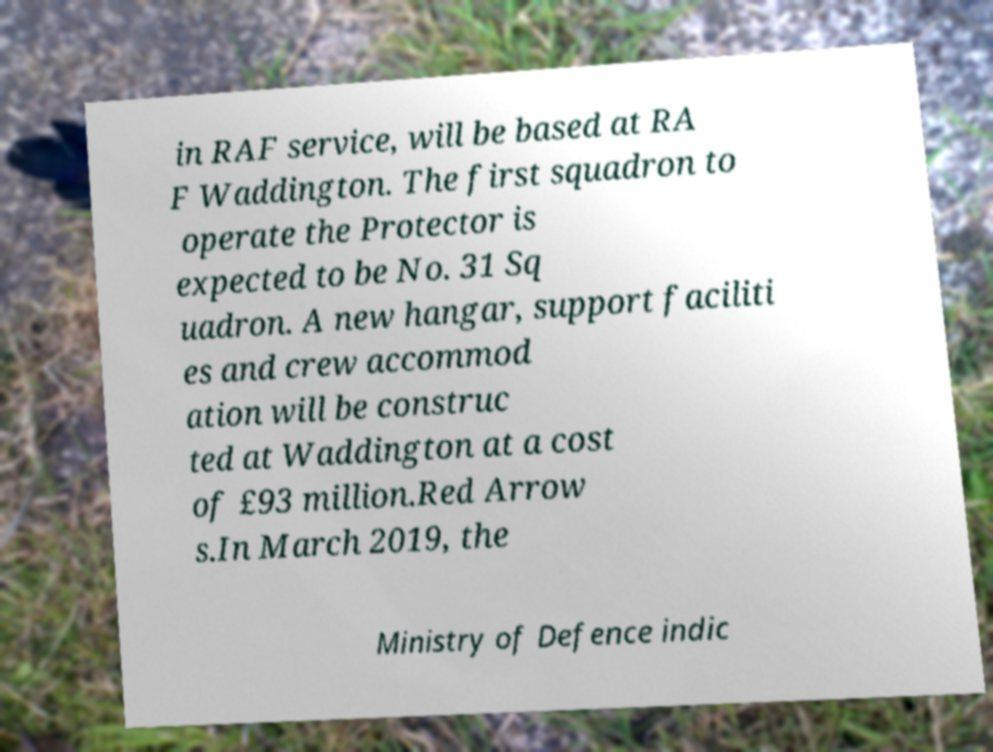Could you extract and type out the text from this image? in RAF service, will be based at RA F Waddington. The first squadron to operate the Protector is expected to be No. 31 Sq uadron. A new hangar, support faciliti es and crew accommod ation will be construc ted at Waddington at a cost of £93 million.Red Arrow s.In March 2019, the Ministry of Defence indic 